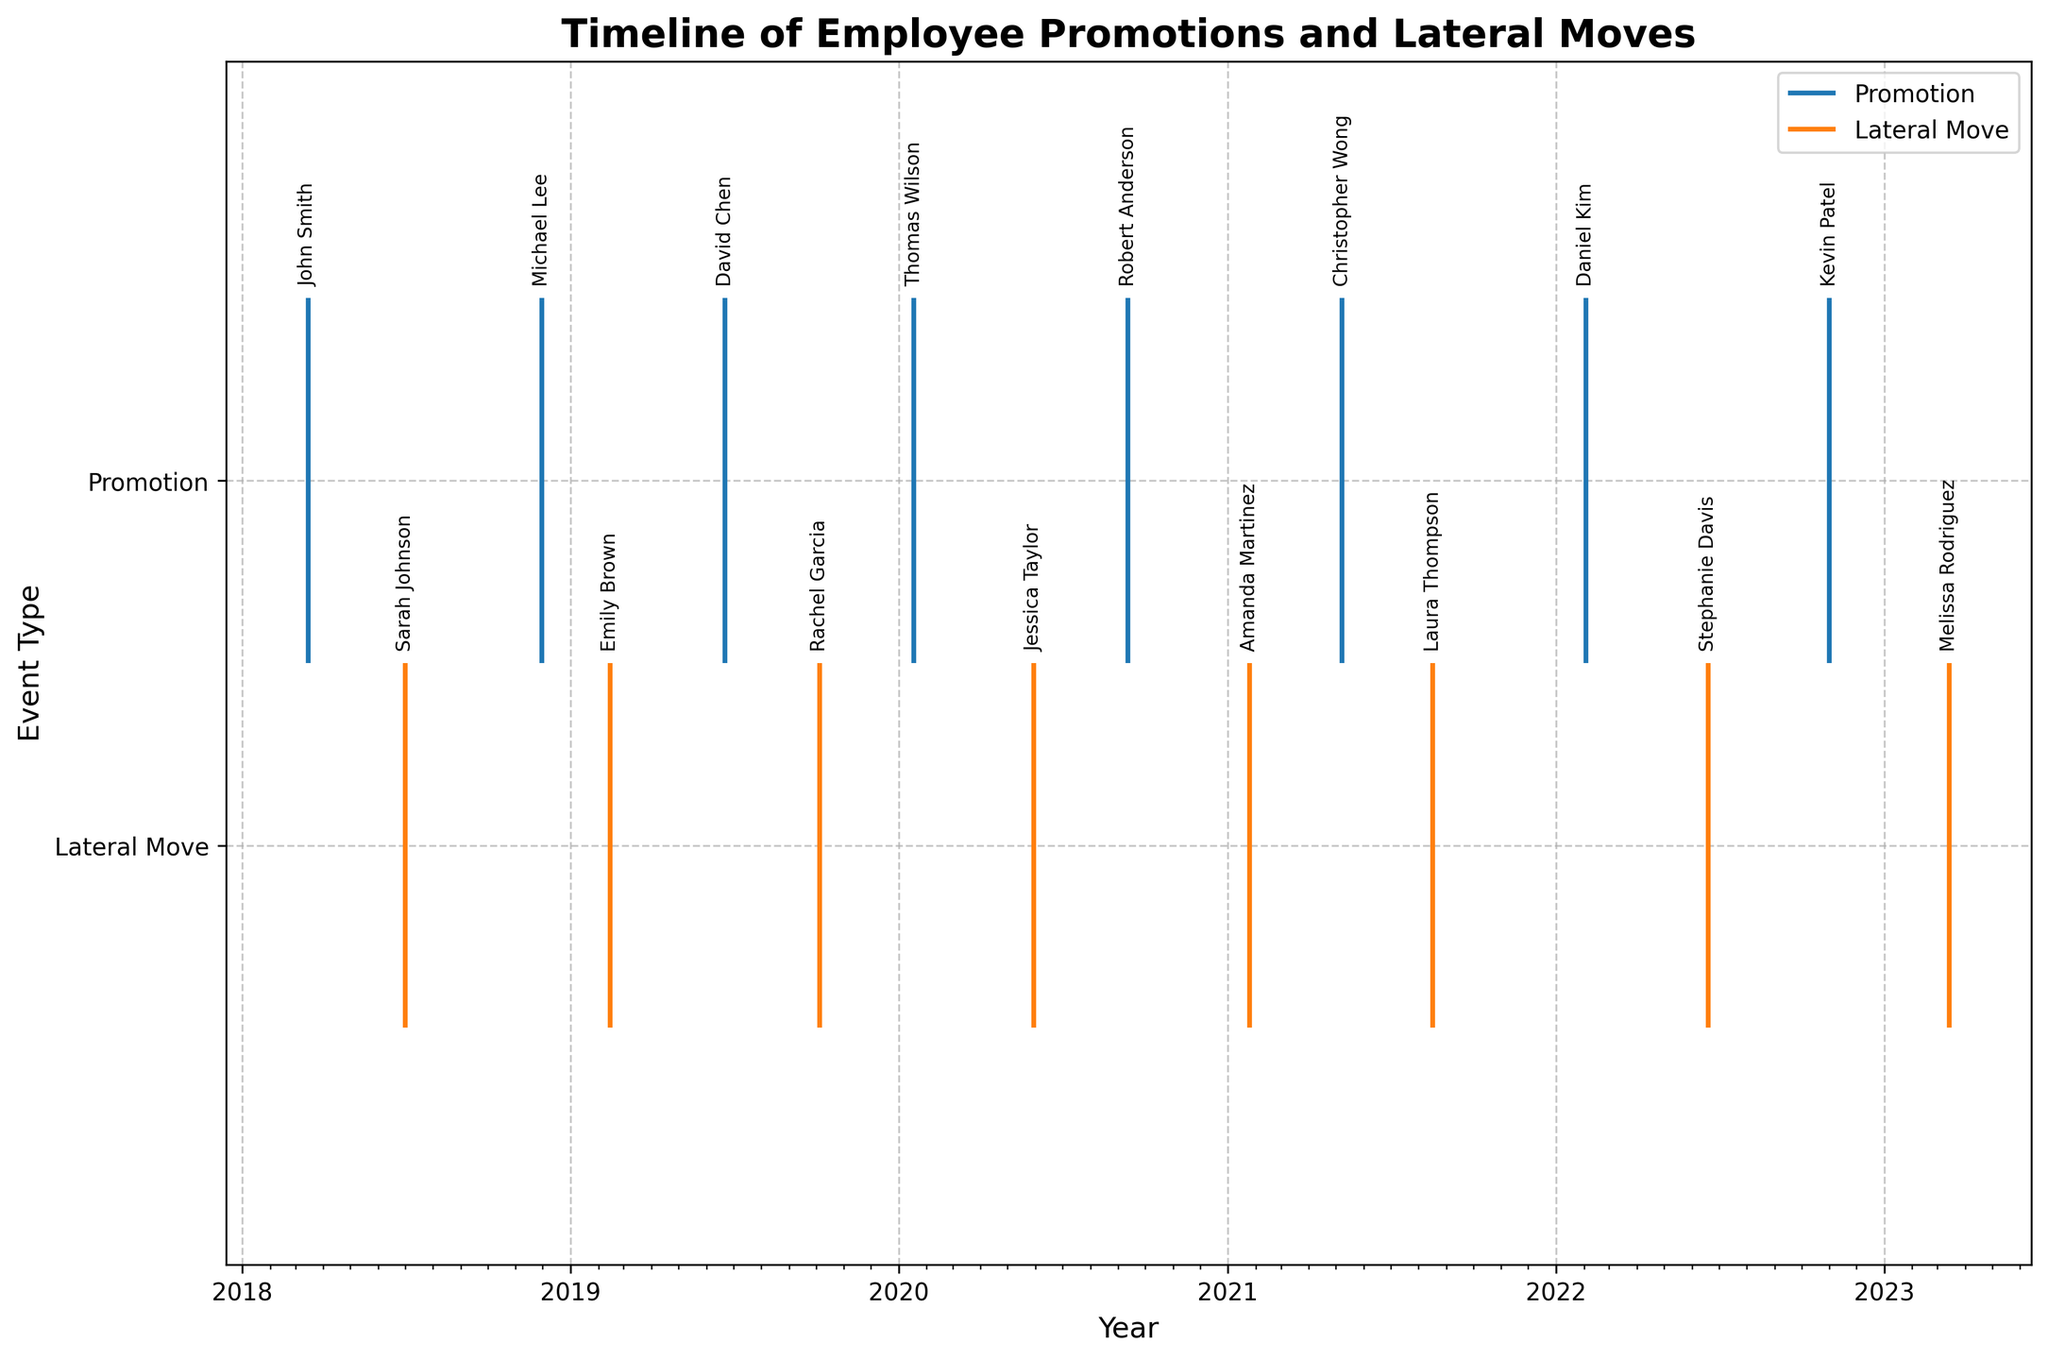What are the two types of events represented in the figure? The y-axis labels indicate two event types shown in the figure: "Promotion" and "Lateral Move". These correspond to the lines at y-values 1 and 0, respectively.
Answer: Promotion and Lateral Move How many employee promotions are displayed in the figure? Each promotional event is represented by a data point along the "Promotion" line offset shown with blue lines. Counting the blue lines, we get: 1, 2, 3, 4, 5, 6, 7, 8.
Answer: 8 In which year was the highest number of lateral moves observed? By observing the distribution of orange lines along the timeline, we count the number of events per year. In 2019, there are 2 events, which is the highest compared to other years.
Answer: 2019 Which employee had a promotion in 2022? The blue line indicating a promotion event in 2022 has an annotation. The name labeled on this timeline event is "Kevin Patel".
Answer: Kevin Patel What is the total number of events (promotions and lateral moves) in the year 2020? To find the number of events in 2020, we count both blue and orange lines within that year. There are 3 events in total: 2 promotions and 1 lateral move.
Answer: 3 Compare the number of promotional events in 2018 and 2021. Which year had more? There are 2 promotional events in 2018 (blue lines), and 2 in 2021. Both years had an equal number of promotional events.
Answer: Equal Which employee had a lateral move just before or after their promotion (within a year's time)? From the timeline, "Christopher Wong" had a promotion in May 2021, and "Laura Thompson" had a lateral move in August 2021, which falls within a close range of time.
Answer: Laura Thompson Which year had the smallest number of employee promotions? By counting the blue lines in each year, we see that 2020 and 2022 had 2 promotions each, and all other years had either 2 or more, making 2020 and 2022 the years with the smallest.
Answer: 2020 and 2022 What is the average time gap between two consecutive promotions? Calculate the time differences between consecutive promotion dates: (30 Nov 2018 - 15 Mar 2018), (22 Jun 2019 - 30 Nov 2018), (18 Jan 2020 - 22 Jun 2019), (12 Sep 2020 - 18 Jan 2020), (8 May 2021 - 12 Sep 2020), (3 Feb 2022 - 8 May 2021), and (1 Nov 2022 - 3 Feb 2022). Average these differences to find the average gap.
Answer: Approximately 7.5 months Are any lateral moves followed by another lateral move in less than a year? By observing the timeline, Jessica Taylor's lateral move on 30 May 2020 and Amanda Martinez's lateral move on 25 Jan 2021 are less than a year apart.
Answer: Yes 